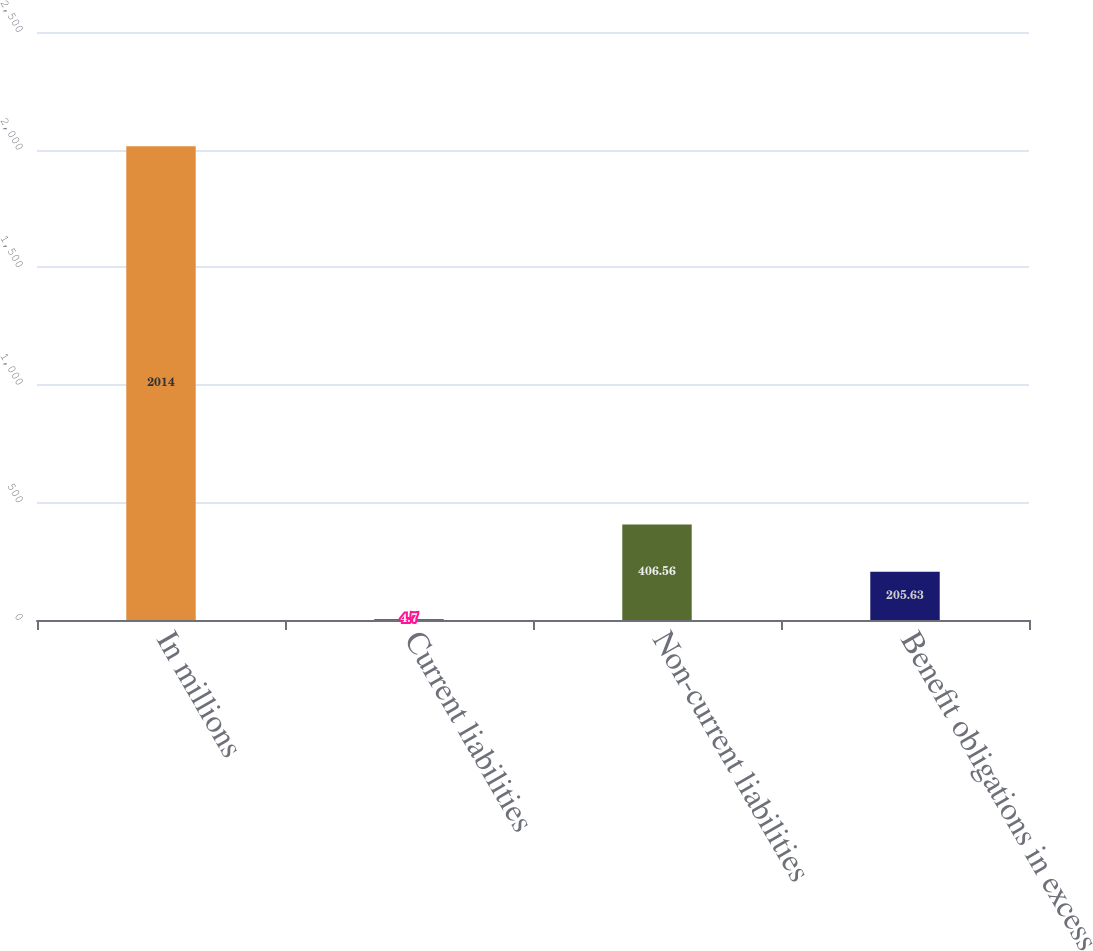<chart> <loc_0><loc_0><loc_500><loc_500><bar_chart><fcel>In millions<fcel>Current liabilities<fcel>Non-current liabilities<fcel>Benefit obligations in excess<nl><fcel>2014<fcel>4.7<fcel>406.56<fcel>205.63<nl></chart> 